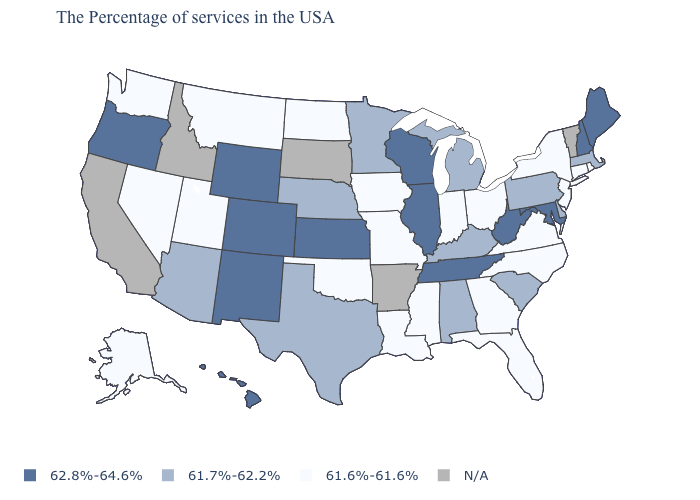Is the legend a continuous bar?
Short answer required. No. Name the states that have a value in the range 61.6%-61.6%?
Answer briefly. Rhode Island, Connecticut, New York, New Jersey, Virginia, North Carolina, Ohio, Florida, Georgia, Indiana, Mississippi, Louisiana, Missouri, Iowa, Oklahoma, North Dakota, Utah, Montana, Nevada, Washington, Alaska. What is the value of Montana?
Give a very brief answer. 61.6%-61.6%. What is the value of Wyoming?
Write a very short answer. 62.8%-64.6%. What is the value of Delaware?
Concise answer only. 61.7%-62.2%. Which states have the lowest value in the MidWest?
Keep it brief. Ohio, Indiana, Missouri, Iowa, North Dakota. Which states have the lowest value in the USA?
Give a very brief answer. Rhode Island, Connecticut, New York, New Jersey, Virginia, North Carolina, Ohio, Florida, Georgia, Indiana, Mississippi, Louisiana, Missouri, Iowa, Oklahoma, North Dakota, Utah, Montana, Nevada, Washington, Alaska. Does Wisconsin have the highest value in the MidWest?
Give a very brief answer. Yes. Which states have the lowest value in the USA?
Write a very short answer. Rhode Island, Connecticut, New York, New Jersey, Virginia, North Carolina, Ohio, Florida, Georgia, Indiana, Mississippi, Louisiana, Missouri, Iowa, Oklahoma, North Dakota, Utah, Montana, Nevada, Washington, Alaska. Name the states that have a value in the range 61.6%-61.6%?
Keep it brief. Rhode Island, Connecticut, New York, New Jersey, Virginia, North Carolina, Ohio, Florida, Georgia, Indiana, Mississippi, Louisiana, Missouri, Iowa, Oklahoma, North Dakota, Utah, Montana, Nevada, Washington, Alaska. Name the states that have a value in the range 62.8%-64.6%?
Be succinct. Maine, New Hampshire, Maryland, West Virginia, Tennessee, Wisconsin, Illinois, Kansas, Wyoming, Colorado, New Mexico, Oregon, Hawaii. What is the lowest value in the South?
Write a very short answer. 61.6%-61.6%. What is the value of Vermont?
Write a very short answer. N/A. Name the states that have a value in the range 61.6%-61.6%?
Short answer required. Rhode Island, Connecticut, New York, New Jersey, Virginia, North Carolina, Ohio, Florida, Georgia, Indiana, Mississippi, Louisiana, Missouri, Iowa, Oklahoma, North Dakota, Utah, Montana, Nevada, Washington, Alaska. 